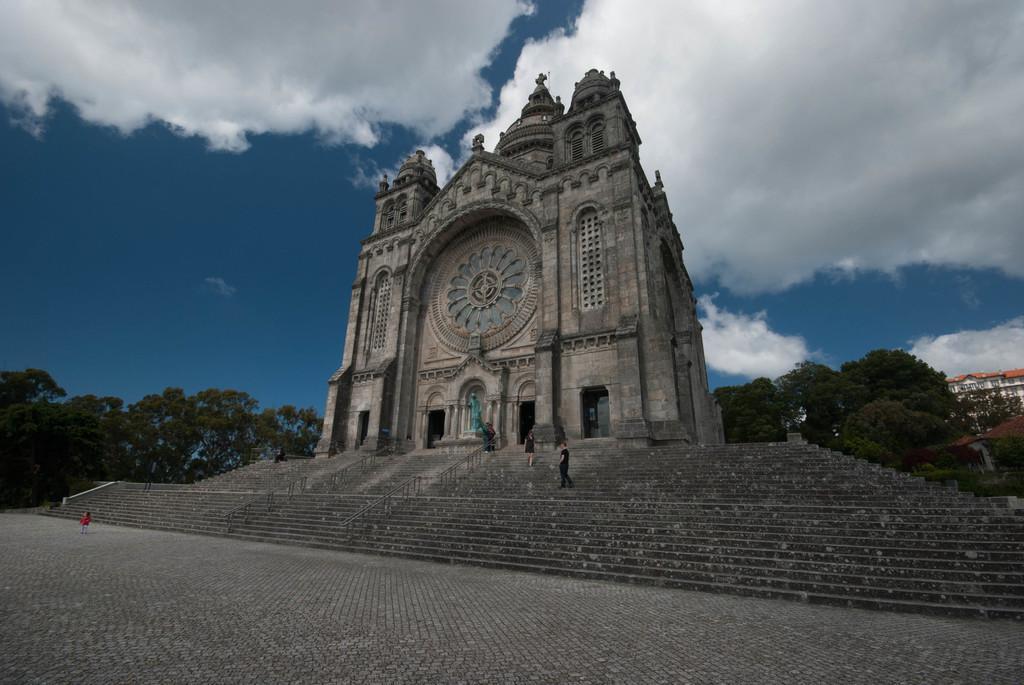In one or two sentences, can you explain what this image depicts? We can see steps,people and building. In the background we can see trees and sky is cloudy. 